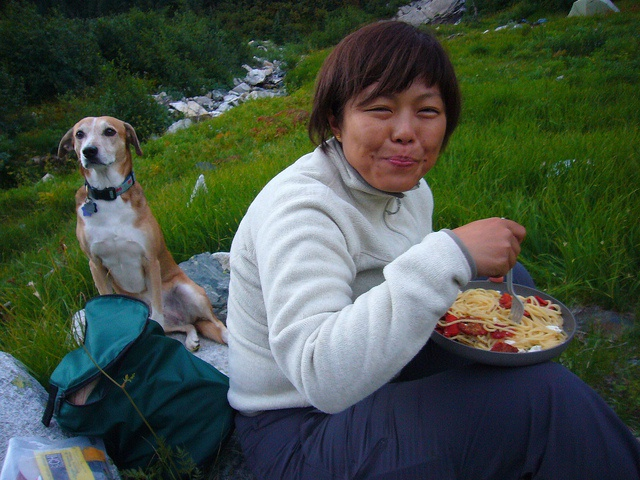Describe the objects in this image and their specific colors. I can see people in black, darkgray, lightgray, and navy tones, handbag in black, teal, and darkblue tones, dog in black, gray, and darkgray tones, bowl in black, tan, gray, and maroon tones, and fork in black, gray, and blue tones in this image. 